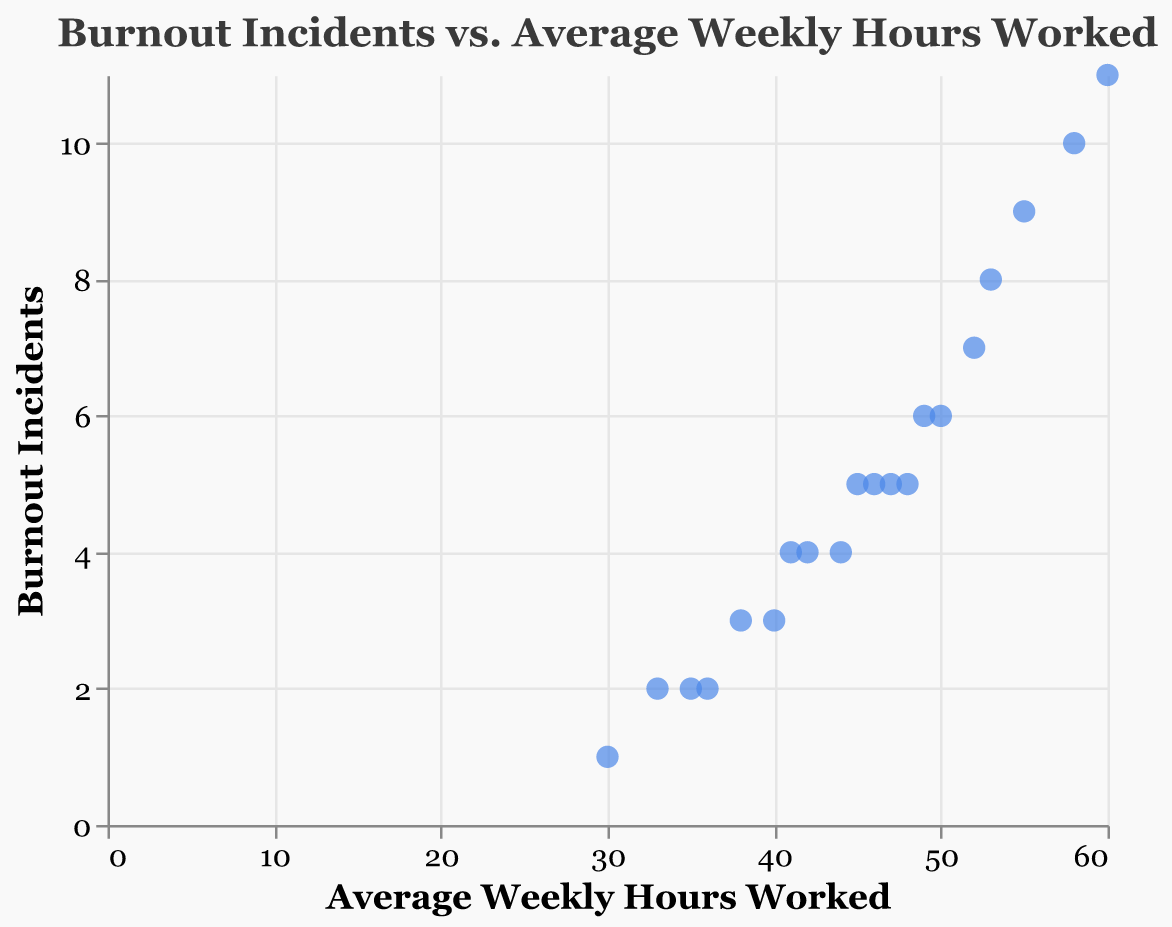What is the title of the scatter plot? The title is usually found at the top of the plot and serves as a summary of what the plot is about. In this case, it reads: "Burnout Incidents vs. Average Weekly Hours Worked".
Answer: Burnout Incidents vs. Average Weekly Hours Worked How many data points are there in the scatter plot? Each data point in a scatter plot represents an individual observation, and we can count the number of points to determine the total. By counting, there are 20 data points in the plot.
Answer: 20 What is the color of the data points in the scatter plot? The color used for the data points helps in visually differentiating them from the background and other elements. Here, it is specified as blue.
Answer: Blue What is the maximum number of Burnout Incidents recorded in the scatter plot? To find the maximum, we look at the data points along the y-axis and identify the highest value. The highest value is at 11 Burnout Incidents.
Answer: 11 Which Average Weekly Hours Worked has the lowest number of Burnout Incidents? To determine this, we find the data point with the lowest y-value and note its corresponding x-value. The point (30, 1) indicates 30 weekly hours with 1 burnout incident, the lowest recorded.
Answer: 30 What is the average of the Burnout Incidents for the data points where Average Weekly Hours Worked is exactly 48 and 49? First, identify the points: (48, 5) and (49, 6). Calculate the average of the y-values: (5 + 6) / 2 = 5.5.
Answer: 5.5 Is there a relationship between Average Weekly Hours Worked and Burnout Incidents? Observe the overall trend in the scatter plot. As the number of Weekly Hours Worked increases, the number of Burnout Incidents also tends to increase.
Answer: Yes, a positive relationship How many data points have 5 Burnout Incidents recorded? To answer this, we count all data points where the y-value is 5. The data points are (45, 5), (46, 5), (48, 5), and (47, 5), making a total of 4.
Answer: 4 Which data point has the highest Average Weekly Hours Worked and how many Burnout Incidents does it have? Examine the x-axis and find the data point with the highest value, which is (60, 11). It records 60 weekly hours and 11 burnout incidents.
Answer: (60, 11) What is the difference in Burnout Incidents between the data points with 50 and 55 Average Weekly Hours Worked? Identify the points: (50, 6) and (55, 9). The difference in y-values is 9 - 6 = 3.
Answer: 3 